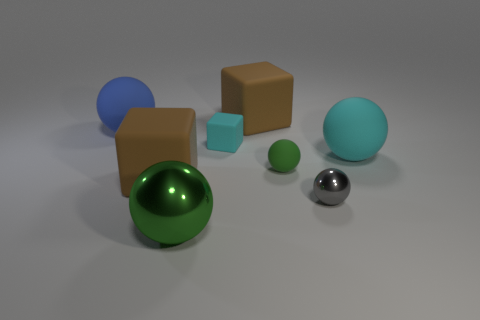Subtract all brown matte cubes. How many cubes are left? 1 Add 1 yellow metallic objects. How many objects exist? 9 Subtract all cyan cubes. How many cubes are left? 2 Subtract 4 balls. How many balls are left? 1 Subtract all blue things. Subtract all large green rubber objects. How many objects are left? 7 Add 1 gray balls. How many gray balls are left? 2 Add 7 tiny purple cylinders. How many tiny purple cylinders exist? 7 Subtract 0 red cylinders. How many objects are left? 8 Subtract all blocks. How many objects are left? 5 Subtract all green cubes. Subtract all brown cylinders. How many cubes are left? 3 